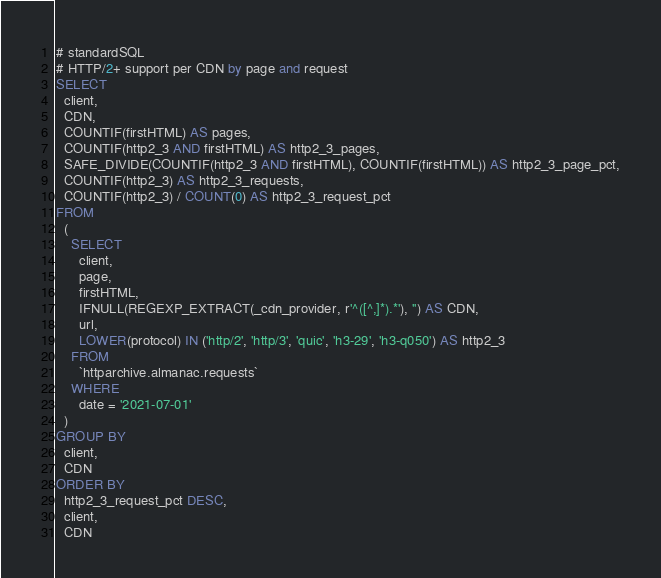Convert code to text. <code><loc_0><loc_0><loc_500><loc_500><_SQL_># standardSQL
# HTTP/2+ support per CDN by page and request
SELECT
  client,
  CDN,
  COUNTIF(firstHTML) AS pages,
  COUNTIF(http2_3 AND firstHTML) AS http2_3_pages,
  SAFE_DIVIDE(COUNTIF(http2_3 AND firstHTML), COUNTIF(firstHTML)) AS http2_3_page_pct,
  COUNTIF(http2_3) AS http2_3_requests,
  COUNTIF(http2_3) / COUNT(0) AS http2_3_request_pct
FROM
  (
    SELECT
      client,
      page,
      firstHTML,
      IFNULL(REGEXP_EXTRACT(_cdn_provider, r'^([^,]*).*'), '') AS CDN,
      url,
      LOWER(protocol) IN ('http/2', 'http/3', 'quic', 'h3-29', 'h3-q050') AS http2_3
    FROM
      `httparchive.almanac.requests`
    WHERE
      date = '2021-07-01'
  )
GROUP BY
  client,
  CDN
ORDER BY
  http2_3_request_pct DESC,
  client,
  CDN
</code> 